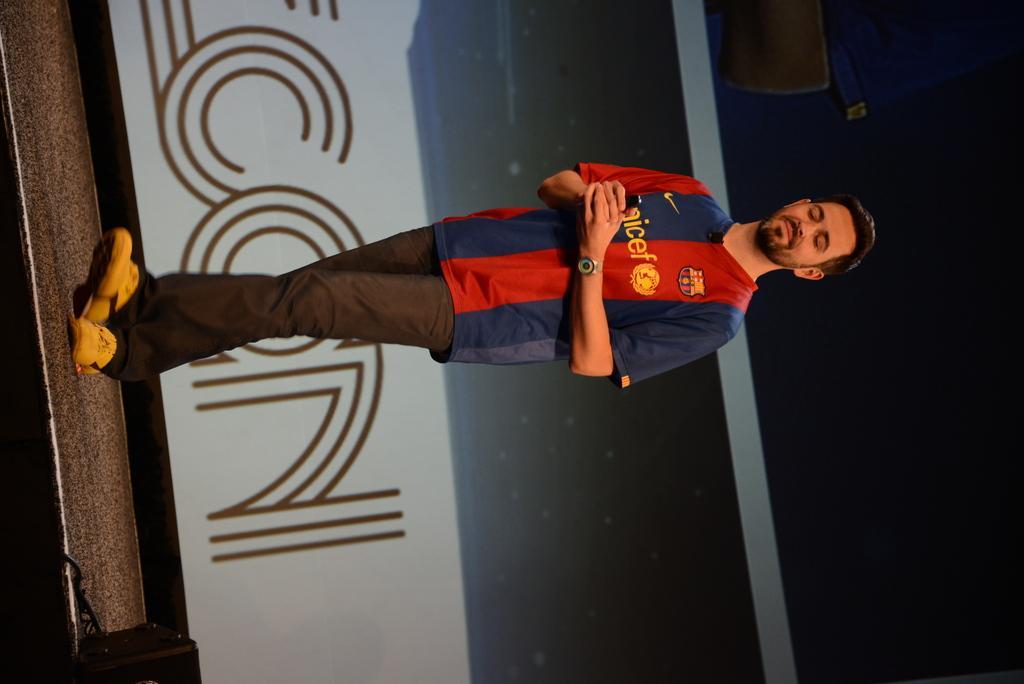Can you describe this image briefly? In the middle of the picture we can see a person walking on the stage. In the background there is a banner. On the right it is dark. 